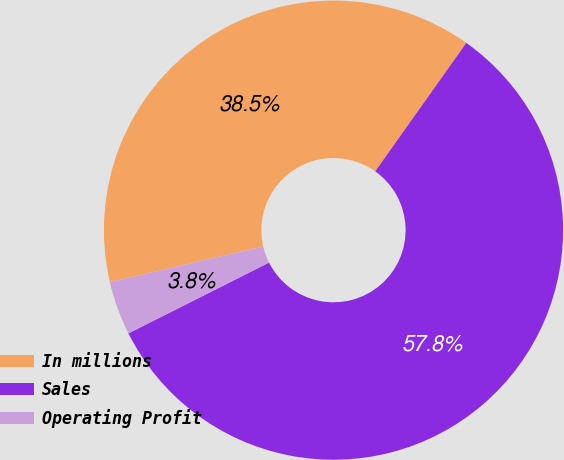<chart> <loc_0><loc_0><loc_500><loc_500><pie_chart><fcel>In millions<fcel>Sales<fcel>Operating Profit<nl><fcel>38.45%<fcel>57.76%<fcel>3.79%<nl></chart> 